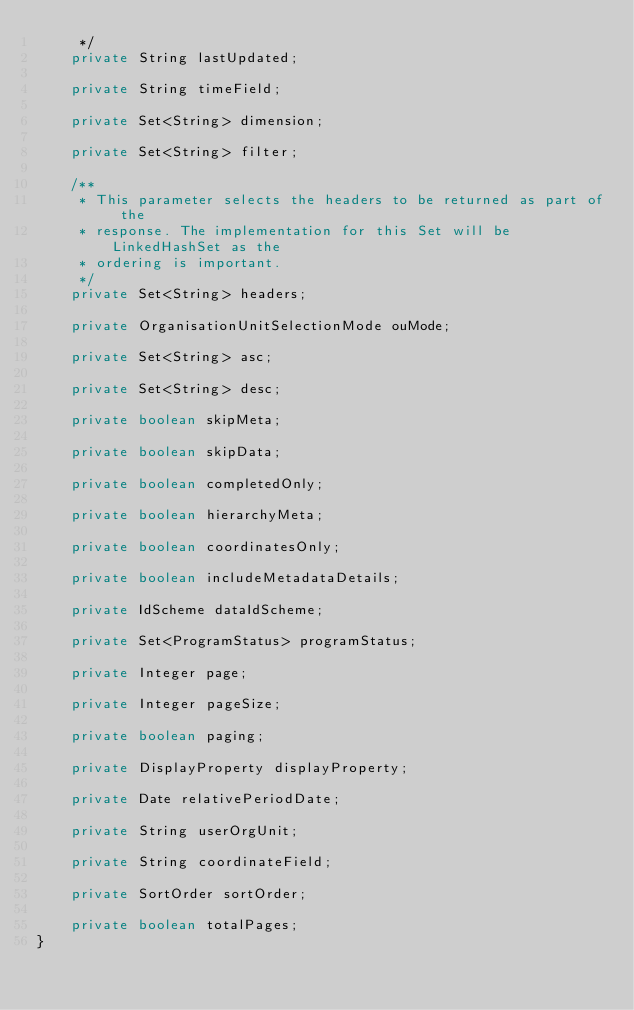Convert code to text. <code><loc_0><loc_0><loc_500><loc_500><_Java_>     */
    private String lastUpdated;

    private String timeField;

    private Set<String> dimension;

    private Set<String> filter;

    /**
     * This parameter selects the headers to be returned as part of the
     * response. The implementation for this Set will be LinkedHashSet as the
     * ordering is important.
     */
    private Set<String> headers;

    private OrganisationUnitSelectionMode ouMode;

    private Set<String> asc;

    private Set<String> desc;

    private boolean skipMeta;

    private boolean skipData;

    private boolean completedOnly;

    private boolean hierarchyMeta;

    private boolean coordinatesOnly;

    private boolean includeMetadataDetails;

    private IdScheme dataIdScheme;

    private Set<ProgramStatus> programStatus;

    private Integer page;

    private Integer pageSize;

    private boolean paging;

    private DisplayProperty displayProperty;

    private Date relativePeriodDate;

    private String userOrgUnit;

    private String coordinateField;

    private SortOrder sortOrder;

    private boolean totalPages;
}
</code> 